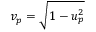Convert formula to latex. <formula><loc_0><loc_0><loc_500><loc_500>v _ { p } = \sqrt { 1 - u _ { p } ^ { 2 } }</formula> 